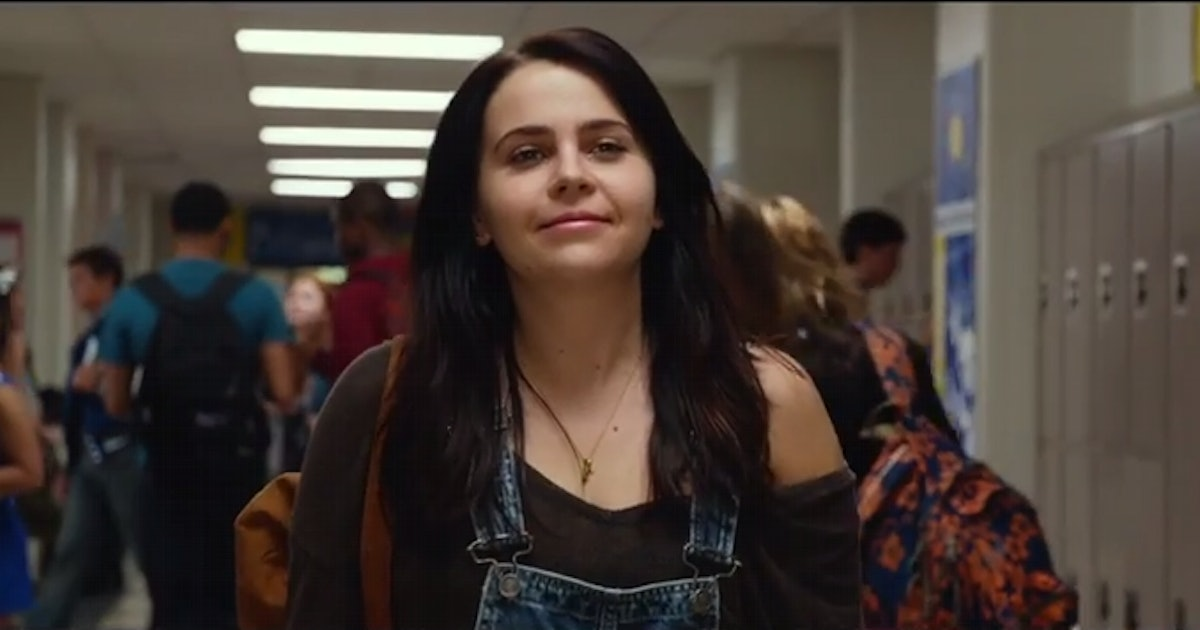What is this photo about? This image features a young woman, likely a high school student, walking through a crowded hallway. She's dressed in a laid-back style with a brown cardigan, black tank top, and denim overalls. There's a distinct confidence in her stride and a subtle, friendly smile on her face. The scene is vibrant with activity, representing a typical school day. This setting possibly suggests a moment from a youth-centric film or series, focusing on teenage life and its complexities. 